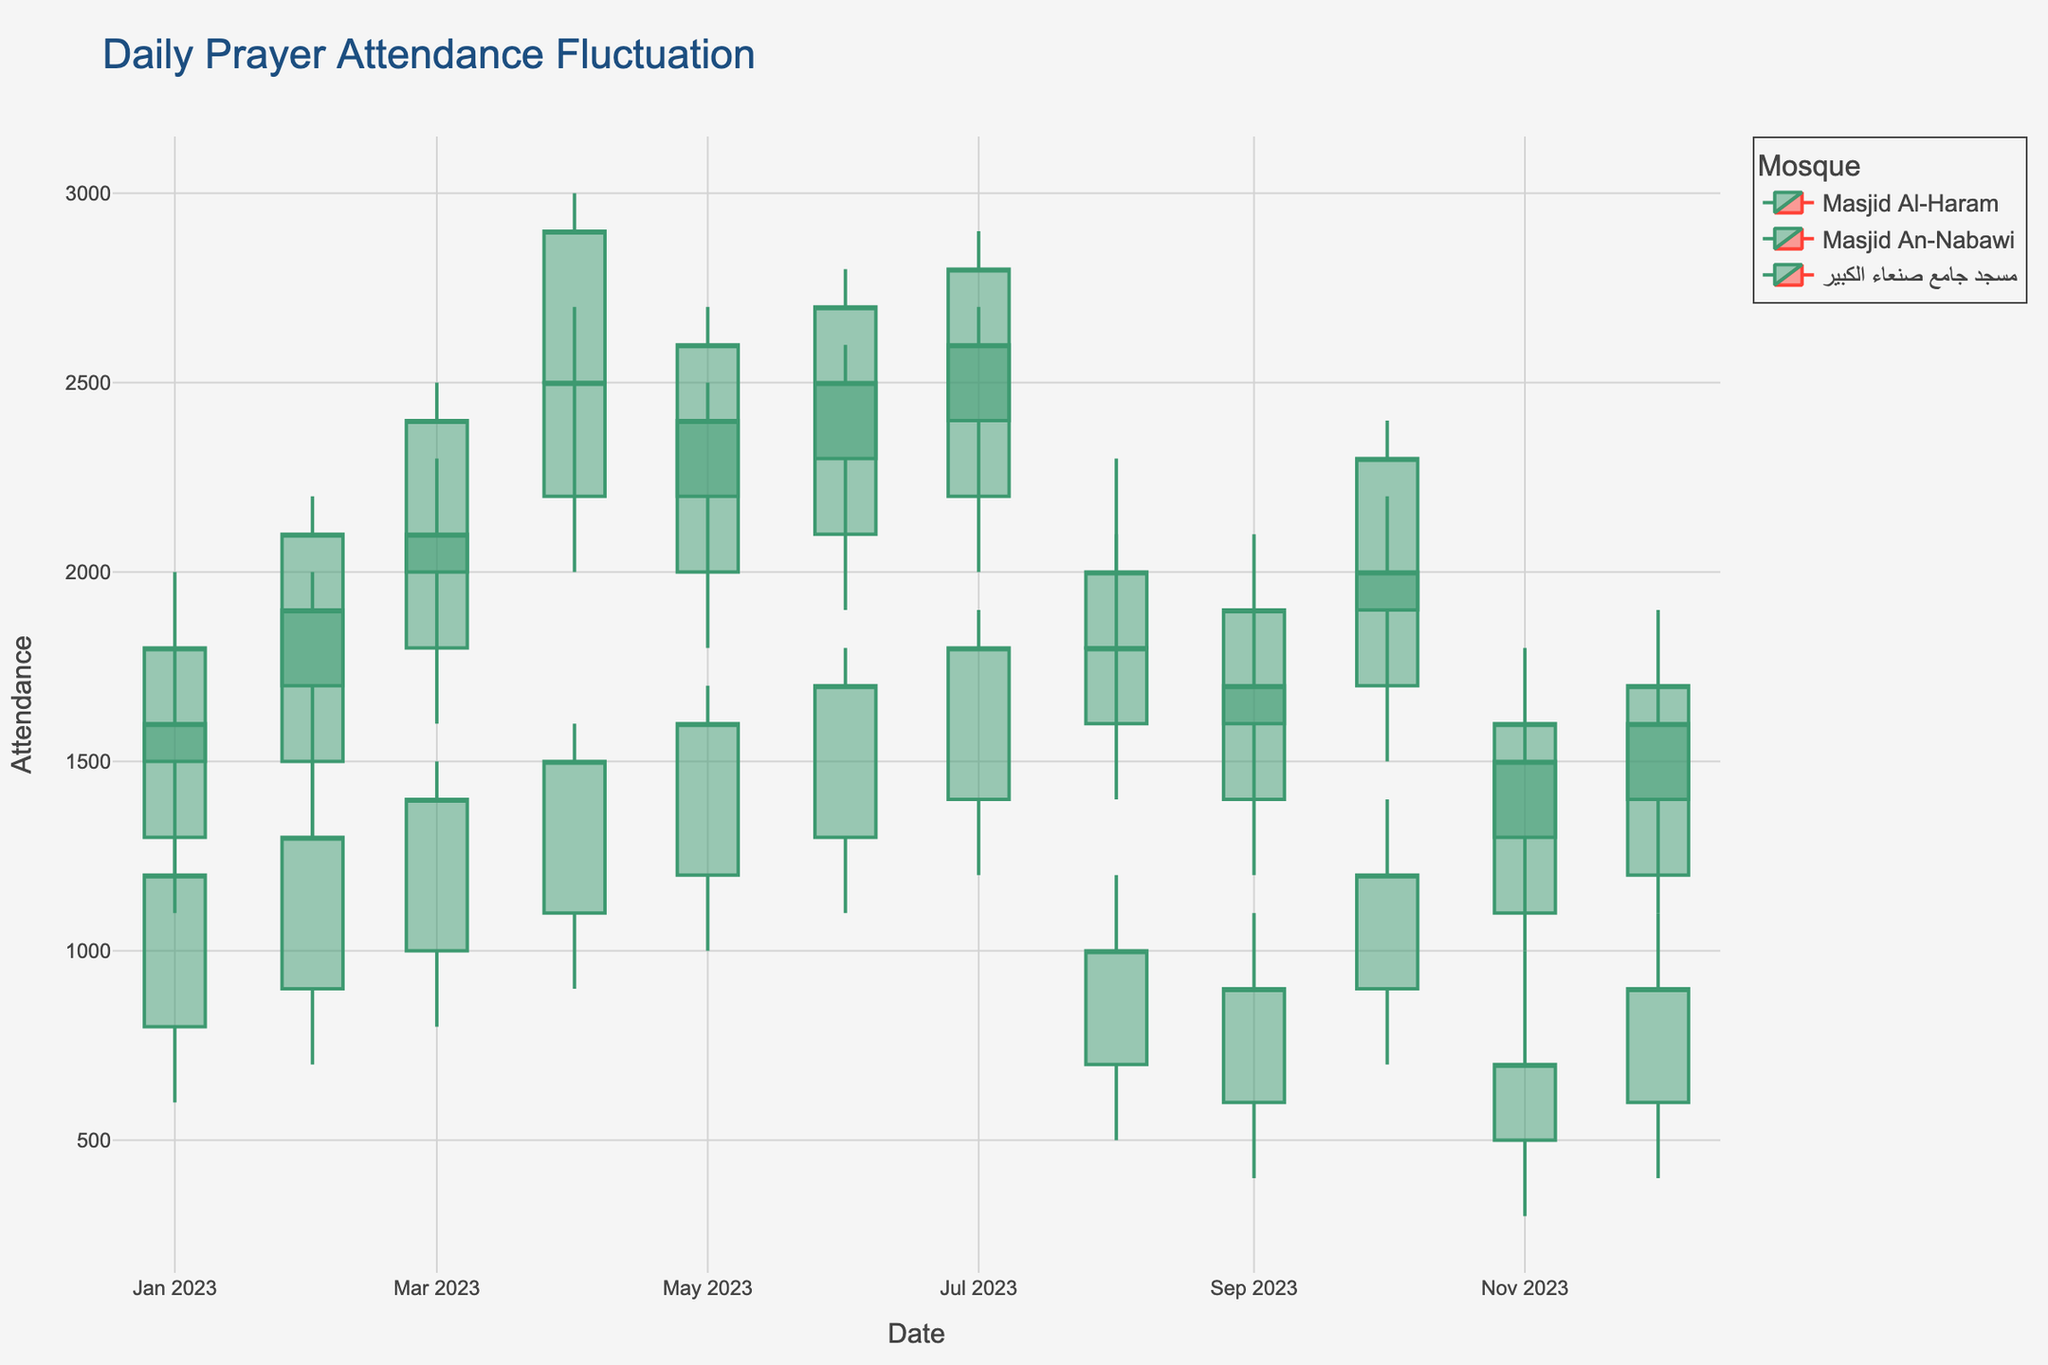what is the title of the figure? The title is usually displayed at the top of the figure. Here, it is evident due to the larger font size and its central position.
Answer: Daily Prayer Attendance Fluctuation Which mosque shows the highest attendance in April 2023? Check each mosque's candlestick for April 2023 and look at the 'High' value for each. Masjid Al-Haram has the highest value at 3000.
Answer: Masjid Al-Haram What is the range of prayer attendance in Masjid An-Nabawi in July 2023? The range is calculated as the difference between the highest (2700) and the lowest (2000) attendance values in July 2023.
Answer: 700 How did the attendance trend for Masjid Al-Haram change from January to April 2023? Examine the 'Close' values from January (1800), February (2100), March (2400), and April (2900). The trend shows a steady increase.
Answer: Increasing Compare the highest attendance between Masjid An-Nabawi and مسجد جامع صنعاء الكبير in February 2023. For February 2023, compare the 'High' values: Masjid An-Nabawi (2000) and مسجد جامع صنعاء الكبير (1400). Masjid An-Nabawi has a higher attendance.
Answer: Masjid An-Nabawi What was the lowest attendance recorded in the year for مسجد جامع صنعاء الكبير? Look at the 'Low' values across all months for مسجد جامع صنعاء الكبير. The lowest attendance recorded is 300 in November 2023.
Answer: 300 During which month did Masjid Al-Haram have the highest fluctuation in attendance? The fluctuation is the difference between the 'High' and 'Low' values. Check each month's fluctuation for Masjid Al-Haram. The highest fluctuation (800) was in April 2023.
Answer: April 2023 What is the average 'Close' attendance for Masjid An-Nabawi in the first quarter of the year? Add the 'Close' values for January (1600), February (1900), and March (2100), then divide the sum by 3. (1600 + 1900 + 2100) / 3 = 5600 / 3 ~ 1867
Answer: 1867 How does the attendance in Masjid Al-Haram in August compare with October 2023? Look at the 'Close' values for both months: August (2000) and October (2300). October has a higher closing attendance.
Answer: October is higher Which month shows the highest opening attendance for مسجد جامع صنعاء الكبير? Check the 'Open' values for مسجد جامع صنعاء الكبير across all months. The highest opening attendance is 1400 in July 2023.
Answer: July 2023 